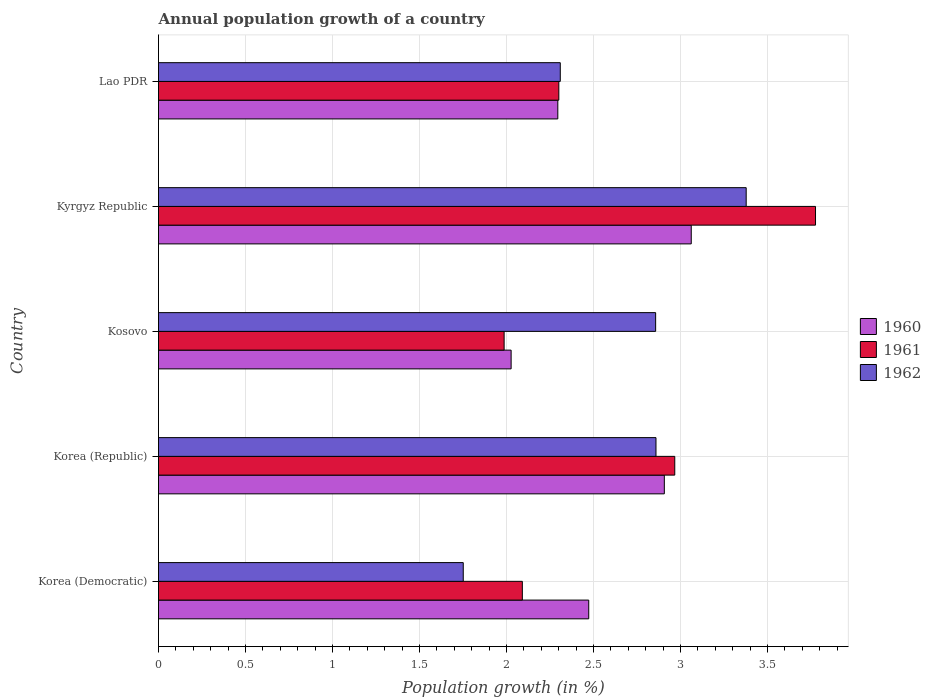How many groups of bars are there?
Provide a succinct answer. 5. Are the number of bars per tick equal to the number of legend labels?
Provide a short and direct response. Yes. How many bars are there on the 4th tick from the top?
Your response must be concise. 3. What is the label of the 1st group of bars from the top?
Give a very brief answer. Lao PDR. What is the annual population growth in 1961 in Kyrgyz Republic?
Provide a succinct answer. 3.78. Across all countries, what is the maximum annual population growth in 1960?
Offer a terse response. 3.06. Across all countries, what is the minimum annual population growth in 1960?
Offer a terse response. 2.03. In which country was the annual population growth in 1960 maximum?
Your response must be concise. Kyrgyz Republic. In which country was the annual population growth in 1962 minimum?
Your response must be concise. Korea (Democratic). What is the total annual population growth in 1960 in the graph?
Give a very brief answer. 12.76. What is the difference between the annual population growth in 1960 in Korea (Democratic) and that in Kyrgyz Republic?
Give a very brief answer. -0.59. What is the difference between the annual population growth in 1960 in Lao PDR and the annual population growth in 1962 in Korea (Republic)?
Make the answer very short. -0.56. What is the average annual population growth in 1960 per country?
Ensure brevity in your answer.  2.55. What is the difference between the annual population growth in 1962 and annual population growth in 1960 in Kosovo?
Ensure brevity in your answer.  0.83. What is the ratio of the annual population growth in 1961 in Korea (Democratic) to that in Kosovo?
Your answer should be very brief. 1.05. Is the annual population growth in 1961 in Korea (Democratic) less than that in Lao PDR?
Provide a short and direct response. Yes. What is the difference between the highest and the second highest annual population growth in 1961?
Your answer should be compact. 0.81. What is the difference between the highest and the lowest annual population growth in 1960?
Offer a terse response. 1.04. Is the sum of the annual population growth in 1962 in Korea (Republic) and Kyrgyz Republic greater than the maximum annual population growth in 1960 across all countries?
Your answer should be very brief. Yes. What does the 1st bar from the top in Kyrgyz Republic represents?
Provide a succinct answer. 1962. What does the 1st bar from the bottom in Kyrgyz Republic represents?
Give a very brief answer. 1960. Is it the case that in every country, the sum of the annual population growth in 1962 and annual population growth in 1960 is greater than the annual population growth in 1961?
Give a very brief answer. Yes. How many bars are there?
Make the answer very short. 15. What is the difference between two consecutive major ticks on the X-axis?
Provide a succinct answer. 0.5. Does the graph contain any zero values?
Your response must be concise. No. How many legend labels are there?
Provide a short and direct response. 3. How are the legend labels stacked?
Keep it short and to the point. Vertical. What is the title of the graph?
Provide a succinct answer. Annual population growth of a country. What is the label or title of the X-axis?
Provide a succinct answer. Population growth (in %). What is the label or title of the Y-axis?
Provide a succinct answer. Country. What is the Population growth (in %) in 1960 in Korea (Democratic)?
Ensure brevity in your answer.  2.47. What is the Population growth (in %) of 1961 in Korea (Democratic)?
Ensure brevity in your answer.  2.09. What is the Population growth (in %) in 1962 in Korea (Democratic)?
Give a very brief answer. 1.75. What is the Population growth (in %) in 1960 in Korea (Republic)?
Offer a very short reply. 2.91. What is the Population growth (in %) of 1961 in Korea (Republic)?
Give a very brief answer. 2.97. What is the Population growth (in %) in 1962 in Korea (Republic)?
Provide a succinct answer. 2.86. What is the Population growth (in %) of 1960 in Kosovo?
Offer a terse response. 2.03. What is the Population growth (in %) of 1961 in Kosovo?
Ensure brevity in your answer.  1.99. What is the Population growth (in %) in 1962 in Kosovo?
Offer a very short reply. 2.86. What is the Population growth (in %) in 1960 in Kyrgyz Republic?
Keep it short and to the point. 3.06. What is the Population growth (in %) in 1961 in Kyrgyz Republic?
Provide a short and direct response. 3.78. What is the Population growth (in %) of 1962 in Kyrgyz Republic?
Offer a very short reply. 3.38. What is the Population growth (in %) of 1960 in Lao PDR?
Offer a very short reply. 2.3. What is the Population growth (in %) of 1961 in Lao PDR?
Your response must be concise. 2.3. What is the Population growth (in %) in 1962 in Lao PDR?
Keep it short and to the point. 2.31. Across all countries, what is the maximum Population growth (in %) in 1960?
Give a very brief answer. 3.06. Across all countries, what is the maximum Population growth (in %) of 1961?
Keep it short and to the point. 3.78. Across all countries, what is the maximum Population growth (in %) in 1962?
Keep it short and to the point. 3.38. Across all countries, what is the minimum Population growth (in %) in 1960?
Ensure brevity in your answer.  2.03. Across all countries, what is the minimum Population growth (in %) of 1961?
Keep it short and to the point. 1.99. Across all countries, what is the minimum Population growth (in %) of 1962?
Your answer should be compact. 1.75. What is the total Population growth (in %) of 1960 in the graph?
Provide a succinct answer. 12.76. What is the total Population growth (in %) in 1961 in the graph?
Provide a succinct answer. 13.12. What is the total Population growth (in %) of 1962 in the graph?
Offer a terse response. 13.16. What is the difference between the Population growth (in %) of 1960 in Korea (Democratic) and that in Korea (Republic)?
Offer a very short reply. -0.43. What is the difference between the Population growth (in %) in 1961 in Korea (Democratic) and that in Korea (Republic)?
Keep it short and to the point. -0.88. What is the difference between the Population growth (in %) of 1962 in Korea (Democratic) and that in Korea (Republic)?
Give a very brief answer. -1.11. What is the difference between the Population growth (in %) in 1960 in Korea (Democratic) and that in Kosovo?
Your answer should be very brief. 0.45. What is the difference between the Population growth (in %) of 1961 in Korea (Democratic) and that in Kosovo?
Your response must be concise. 0.1. What is the difference between the Population growth (in %) in 1962 in Korea (Democratic) and that in Kosovo?
Your answer should be very brief. -1.11. What is the difference between the Population growth (in %) in 1960 in Korea (Democratic) and that in Kyrgyz Republic?
Offer a very short reply. -0.59. What is the difference between the Population growth (in %) in 1961 in Korea (Democratic) and that in Kyrgyz Republic?
Provide a short and direct response. -1.69. What is the difference between the Population growth (in %) in 1962 in Korea (Democratic) and that in Kyrgyz Republic?
Give a very brief answer. -1.63. What is the difference between the Population growth (in %) of 1960 in Korea (Democratic) and that in Lao PDR?
Keep it short and to the point. 0.18. What is the difference between the Population growth (in %) in 1961 in Korea (Democratic) and that in Lao PDR?
Provide a succinct answer. -0.21. What is the difference between the Population growth (in %) of 1962 in Korea (Democratic) and that in Lao PDR?
Keep it short and to the point. -0.56. What is the difference between the Population growth (in %) of 1960 in Korea (Republic) and that in Kosovo?
Offer a very short reply. 0.88. What is the difference between the Population growth (in %) of 1961 in Korea (Republic) and that in Kosovo?
Provide a succinct answer. 0.98. What is the difference between the Population growth (in %) in 1962 in Korea (Republic) and that in Kosovo?
Keep it short and to the point. 0. What is the difference between the Population growth (in %) of 1960 in Korea (Republic) and that in Kyrgyz Republic?
Offer a very short reply. -0.15. What is the difference between the Population growth (in %) in 1961 in Korea (Republic) and that in Kyrgyz Republic?
Offer a very short reply. -0.81. What is the difference between the Population growth (in %) of 1962 in Korea (Republic) and that in Kyrgyz Republic?
Your answer should be compact. -0.52. What is the difference between the Population growth (in %) of 1960 in Korea (Republic) and that in Lao PDR?
Ensure brevity in your answer.  0.61. What is the difference between the Population growth (in %) of 1961 in Korea (Republic) and that in Lao PDR?
Offer a terse response. 0.67. What is the difference between the Population growth (in %) in 1962 in Korea (Republic) and that in Lao PDR?
Offer a terse response. 0.55. What is the difference between the Population growth (in %) of 1960 in Kosovo and that in Kyrgyz Republic?
Make the answer very short. -1.04. What is the difference between the Population growth (in %) in 1961 in Kosovo and that in Kyrgyz Republic?
Ensure brevity in your answer.  -1.79. What is the difference between the Population growth (in %) of 1962 in Kosovo and that in Kyrgyz Republic?
Your answer should be compact. -0.52. What is the difference between the Population growth (in %) of 1960 in Kosovo and that in Lao PDR?
Give a very brief answer. -0.27. What is the difference between the Population growth (in %) of 1961 in Kosovo and that in Lao PDR?
Your response must be concise. -0.31. What is the difference between the Population growth (in %) of 1962 in Kosovo and that in Lao PDR?
Offer a very short reply. 0.55. What is the difference between the Population growth (in %) of 1960 in Kyrgyz Republic and that in Lao PDR?
Offer a terse response. 0.77. What is the difference between the Population growth (in %) of 1961 in Kyrgyz Republic and that in Lao PDR?
Your response must be concise. 1.48. What is the difference between the Population growth (in %) in 1962 in Kyrgyz Republic and that in Lao PDR?
Keep it short and to the point. 1.07. What is the difference between the Population growth (in %) in 1960 in Korea (Democratic) and the Population growth (in %) in 1961 in Korea (Republic)?
Provide a short and direct response. -0.49. What is the difference between the Population growth (in %) of 1960 in Korea (Democratic) and the Population growth (in %) of 1962 in Korea (Republic)?
Offer a very short reply. -0.39. What is the difference between the Population growth (in %) in 1961 in Korea (Democratic) and the Population growth (in %) in 1962 in Korea (Republic)?
Provide a short and direct response. -0.77. What is the difference between the Population growth (in %) in 1960 in Korea (Democratic) and the Population growth (in %) in 1961 in Kosovo?
Keep it short and to the point. 0.49. What is the difference between the Population growth (in %) in 1960 in Korea (Democratic) and the Population growth (in %) in 1962 in Kosovo?
Ensure brevity in your answer.  -0.38. What is the difference between the Population growth (in %) in 1961 in Korea (Democratic) and the Population growth (in %) in 1962 in Kosovo?
Ensure brevity in your answer.  -0.77. What is the difference between the Population growth (in %) of 1960 in Korea (Democratic) and the Population growth (in %) of 1961 in Kyrgyz Republic?
Offer a terse response. -1.3. What is the difference between the Population growth (in %) of 1960 in Korea (Democratic) and the Population growth (in %) of 1962 in Kyrgyz Republic?
Offer a terse response. -0.91. What is the difference between the Population growth (in %) of 1961 in Korea (Democratic) and the Population growth (in %) of 1962 in Kyrgyz Republic?
Offer a very short reply. -1.29. What is the difference between the Population growth (in %) in 1960 in Korea (Democratic) and the Population growth (in %) in 1961 in Lao PDR?
Your response must be concise. 0.17. What is the difference between the Population growth (in %) in 1960 in Korea (Democratic) and the Population growth (in %) in 1962 in Lao PDR?
Provide a short and direct response. 0.16. What is the difference between the Population growth (in %) of 1961 in Korea (Democratic) and the Population growth (in %) of 1962 in Lao PDR?
Offer a very short reply. -0.22. What is the difference between the Population growth (in %) of 1960 in Korea (Republic) and the Population growth (in %) of 1961 in Kosovo?
Make the answer very short. 0.92. What is the difference between the Population growth (in %) in 1960 in Korea (Republic) and the Population growth (in %) in 1962 in Kosovo?
Give a very brief answer. 0.05. What is the difference between the Population growth (in %) in 1961 in Korea (Republic) and the Population growth (in %) in 1962 in Kosovo?
Keep it short and to the point. 0.11. What is the difference between the Population growth (in %) of 1960 in Korea (Republic) and the Population growth (in %) of 1961 in Kyrgyz Republic?
Your answer should be compact. -0.87. What is the difference between the Population growth (in %) in 1960 in Korea (Republic) and the Population growth (in %) in 1962 in Kyrgyz Republic?
Make the answer very short. -0.47. What is the difference between the Population growth (in %) in 1961 in Korea (Republic) and the Population growth (in %) in 1962 in Kyrgyz Republic?
Your response must be concise. -0.41. What is the difference between the Population growth (in %) in 1960 in Korea (Republic) and the Population growth (in %) in 1961 in Lao PDR?
Give a very brief answer. 0.61. What is the difference between the Population growth (in %) in 1960 in Korea (Republic) and the Population growth (in %) in 1962 in Lao PDR?
Your answer should be compact. 0.6. What is the difference between the Population growth (in %) of 1961 in Korea (Republic) and the Population growth (in %) of 1962 in Lao PDR?
Offer a terse response. 0.66. What is the difference between the Population growth (in %) in 1960 in Kosovo and the Population growth (in %) in 1961 in Kyrgyz Republic?
Offer a terse response. -1.75. What is the difference between the Population growth (in %) of 1960 in Kosovo and the Population growth (in %) of 1962 in Kyrgyz Republic?
Provide a short and direct response. -1.35. What is the difference between the Population growth (in %) of 1961 in Kosovo and the Population growth (in %) of 1962 in Kyrgyz Republic?
Provide a succinct answer. -1.39. What is the difference between the Population growth (in %) of 1960 in Kosovo and the Population growth (in %) of 1961 in Lao PDR?
Make the answer very short. -0.27. What is the difference between the Population growth (in %) in 1960 in Kosovo and the Population growth (in %) in 1962 in Lao PDR?
Make the answer very short. -0.28. What is the difference between the Population growth (in %) in 1961 in Kosovo and the Population growth (in %) in 1962 in Lao PDR?
Offer a very short reply. -0.32. What is the difference between the Population growth (in %) in 1960 in Kyrgyz Republic and the Population growth (in %) in 1961 in Lao PDR?
Offer a terse response. 0.76. What is the difference between the Population growth (in %) in 1960 in Kyrgyz Republic and the Population growth (in %) in 1962 in Lao PDR?
Provide a succinct answer. 0.75. What is the difference between the Population growth (in %) in 1961 in Kyrgyz Republic and the Population growth (in %) in 1962 in Lao PDR?
Provide a short and direct response. 1.47. What is the average Population growth (in %) in 1960 per country?
Provide a short and direct response. 2.55. What is the average Population growth (in %) in 1961 per country?
Provide a succinct answer. 2.62. What is the average Population growth (in %) of 1962 per country?
Keep it short and to the point. 2.63. What is the difference between the Population growth (in %) of 1960 and Population growth (in %) of 1961 in Korea (Democratic)?
Your answer should be compact. 0.38. What is the difference between the Population growth (in %) in 1960 and Population growth (in %) in 1962 in Korea (Democratic)?
Provide a succinct answer. 0.72. What is the difference between the Population growth (in %) in 1961 and Population growth (in %) in 1962 in Korea (Democratic)?
Keep it short and to the point. 0.34. What is the difference between the Population growth (in %) in 1960 and Population growth (in %) in 1961 in Korea (Republic)?
Your response must be concise. -0.06. What is the difference between the Population growth (in %) of 1960 and Population growth (in %) of 1962 in Korea (Republic)?
Ensure brevity in your answer.  0.05. What is the difference between the Population growth (in %) in 1961 and Population growth (in %) in 1962 in Korea (Republic)?
Offer a terse response. 0.11. What is the difference between the Population growth (in %) in 1960 and Population growth (in %) in 1961 in Kosovo?
Ensure brevity in your answer.  0.04. What is the difference between the Population growth (in %) of 1960 and Population growth (in %) of 1962 in Kosovo?
Make the answer very short. -0.83. What is the difference between the Population growth (in %) of 1961 and Population growth (in %) of 1962 in Kosovo?
Keep it short and to the point. -0.87. What is the difference between the Population growth (in %) of 1960 and Population growth (in %) of 1961 in Kyrgyz Republic?
Your response must be concise. -0.71. What is the difference between the Population growth (in %) in 1960 and Population growth (in %) in 1962 in Kyrgyz Republic?
Give a very brief answer. -0.32. What is the difference between the Population growth (in %) in 1961 and Population growth (in %) in 1962 in Kyrgyz Republic?
Provide a succinct answer. 0.4. What is the difference between the Population growth (in %) in 1960 and Population growth (in %) in 1961 in Lao PDR?
Offer a terse response. -0.01. What is the difference between the Population growth (in %) in 1960 and Population growth (in %) in 1962 in Lao PDR?
Ensure brevity in your answer.  -0.01. What is the difference between the Population growth (in %) of 1961 and Population growth (in %) of 1962 in Lao PDR?
Keep it short and to the point. -0.01. What is the ratio of the Population growth (in %) of 1960 in Korea (Democratic) to that in Korea (Republic)?
Your answer should be compact. 0.85. What is the ratio of the Population growth (in %) in 1961 in Korea (Democratic) to that in Korea (Republic)?
Provide a succinct answer. 0.7. What is the ratio of the Population growth (in %) in 1962 in Korea (Democratic) to that in Korea (Republic)?
Offer a terse response. 0.61. What is the ratio of the Population growth (in %) in 1960 in Korea (Democratic) to that in Kosovo?
Keep it short and to the point. 1.22. What is the ratio of the Population growth (in %) in 1961 in Korea (Democratic) to that in Kosovo?
Offer a very short reply. 1.05. What is the ratio of the Population growth (in %) in 1962 in Korea (Democratic) to that in Kosovo?
Keep it short and to the point. 0.61. What is the ratio of the Population growth (in %) in 1960 in Korea (Democratic) to that in Kyrgyz Republic?
Ensure brevity in your answer.  0.81. What is the ratio of the Population growth (in %) of 1961 in Korea (Democratic) to that in Kyrgyz Republic?
Provide a short and direct response. 0.55. What is the ratio of the Population growth (in %) in 1962 in Korea (Democratic) to that in Kyrgyz Republic?
Your answer should be compact. 0.52. What is the ratio of the Population growth (in %) of 1960 in Korea (Democratic) to that in Lao PDR?
Make the answer very short. 1.08. What is the ratio of the Population growth (in %) in 1961 in Korea (Democratic) to that in Lao PDR?
Give a very brief answer. 0.91. What is the ratio of the Population growth (in %) of 1962 in Korea (Democratic) to that in Lao PDR?
Make the answer very short. 0.76. What is the ratio of the Population growth (in %) in 1960 in Korea (Republic) to that in Kosovo?
Your answer should be very brief. 1.43. What is the ratio of the Population growth (in %) in 1961 in Korea (Republic) to that in Kosovo?
Your answer should be compact. 1.49. What is the ratio of the Population growth (in %) in 1960 in Korea (Republic) to that in Kyrgyz Republic?
Ensure brevity in your answer.  0.95. What is the ratio of the Population growth (in %) of 1961 in Korea (Republic) to that in Kyrgyz Republic?
Offer a very short reply. 0.79. What is the ratio of the Population growth (in %) in 1962 in Korea (Republic) to that in Kyrgyz Republic?
Ensure brevity in your answer.  0.85. What is the ratio of the Population growth (in %) in 1960 in Korea (Republic) to that in Lao PDR?
Keep it short and to the point. 1.27. What is the ratio of the Population growth (in %) in 1961 in Korea (Republic) to that in Lao PDR?
Your response must be concise. 1.29. What is the ratio of the Population growth (in %) in 1962 in Korea (Republic) to that in Lao PDR?
Offer a terse response. 1.24. What is the ratio of the Population growth (in %) of 1960 in Kosovo to that in Kyrgyz Republic?
Your answer should be very brief. 0.66. What is the ratio of the Population growth (in %) in 1961 in Kosovo to that in Kyrgyz Republic?
Provide a succinct answer. 0.53. What is the ratio of the Population growth (in %) of 1962 in Kosovo to that in Kyrgyz Republic?
Offer a very short reply. 0.85. What is the ratio of the Population growth (in %) of 1960 in Kosovo to that in Lao PDR?
Provide a succinct answer. 0.88. What is the ratio of the Population growth (in %) in 1961 in Kosovo to that in Lao PDR?
Your answer should be very brief. 0.86. What is the ratio of the Population growth (in %) of 1962 in Kosovo to that in Lao PDR?
Offer a very short reply. 1.24. What is the ratio of the Population growth (in %) in 1960 in Kyrgyz Republic to that in Lao PDR?
Give a very brief answer. 1.33. What is the ratio of the Population growth (in %) in 1961 in Kyrgyz Republic to that in Lao PDR?
Provide a short and direct response. 1.64. What is the ratio of the Population growth (in %) in 1962 in Kyrgyz Republic to that in Lao PDR?
Offer a terse response. 1.46. What is the difference between the highest and the second highest Population growth (in %) of 1960?
Your answer should be very brief. 0.15. What is the difference between the highest and the second highest Population growth (in %) of 1961?
Ensure brevity in your answer.  0.81. What is the difference between the highest and the second highest Population growth (in %) of 1962?
Your answer should be very brief. 0.52. What is the difference between the highest and the lowest Population growth (in %) of 1960?
Your answer should be compact. 1.04. What is the difference between the highest and the lowest Population growth (in %) of 1961?
Give a very brief answer. 1.79. What is the difference between the highest and the lowest Population growth (in %) in 1962?
Give a very brief answer. 1.63. 